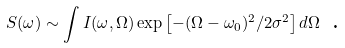Convert formula to latex. <formula><loc_0><loc_0><loc_500><loc_500>S ( \omega ) \sim \int I ( \omega , \Omega ) \exp \left [ - ( \Omega - \omega _ { 0 } ) ^ { 2 } / 2 \sigma ^ { 2 } \right ] d \Omega \text { .}</formula> 